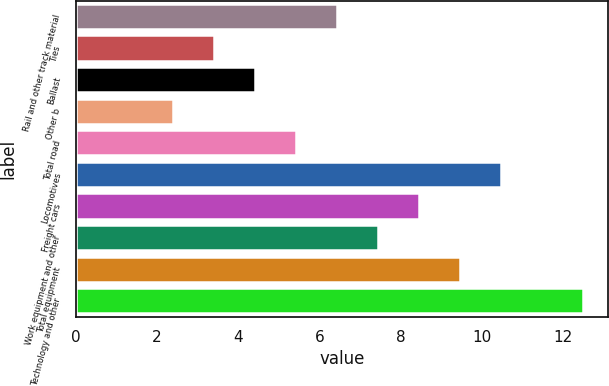<chart> <loc_0><loc_0><loc_500><loc_500><bar_chart><fcel>Rail and other track material<fcel>Ties<fcel>Ballast<fcel>Other b<fcel>Total road<fcel>Locomotives<fcel>Freight cars<fcel>Work equipment and other<fcel>Total equipment<fcel>Technology and other<nl><fcel>6.44<fcel>3.41<fcel>4.42<fcel>2.4<fcel>5.43<fcel>10.48<fcel>8.46<fcel>7.45<fcel>9.47<fcel>12.5<nl></chart> 